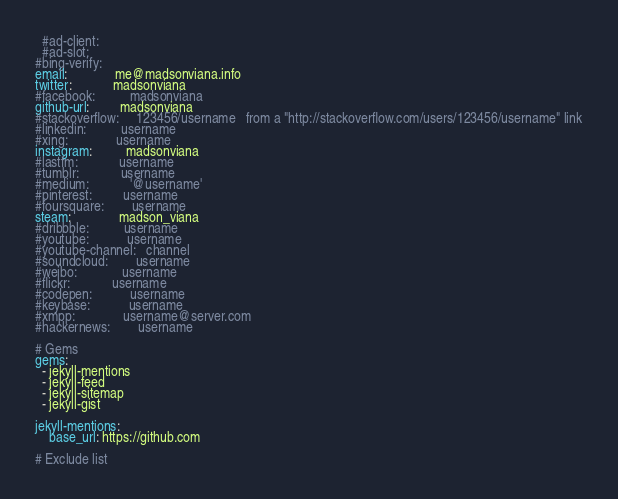Convert code to text. <code><loc_0><loc_0><loc_500><loc_500><_YAML_>  #ad-client:
  #ad-slot:
#bing-verify:
email:              me@madsonviana.info
twitter:            madsonviana
#facebook:          madsonviana
github-url:         madsonviana
#stackoverflow:     123456/username   from a "http://stackoverflow.com/users/123456/username" link
#linkedin:          username
#xing:              username
instagram:          madsonviana
#lastfm:            username
#tumblr:            username
#medium:            '@username'
#pinterest:         username
#foursquare:        username
steam:              madson_viana
#dribbble:          username
#youtube:           username
#youtube-channel:   channel
#soundcloud:        username
#weibo:             username
#flickr:            username
#codepen:           username
#keybase:           username
#xmpp:              username@server.com
#hackernews:        username

# Gems
gems:
  - jekyll-mentions
  - jekyll-feed
  - jekyll-sitemap
  - jekyll-gist

jekyll-mentions:
    base_url: https://github.com

# Exclude list</code> 